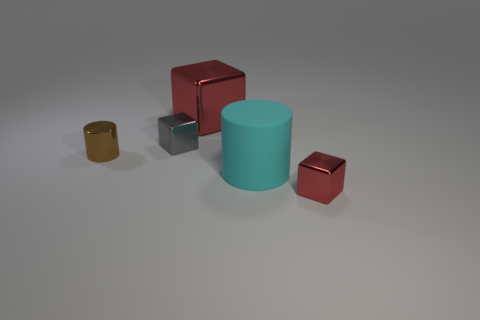Are there any other things that have the same material as the cyan cylinder?
Provide a succinct answer. No. Is there a tiny brown thing that has the same shape as the large cyan object?
Provide a succinct answer. Yes. The tiny object in front of the brown cylinder has what shape?
Keep it short and to the point. Cube. What number of big green metallic cubes are there?
Offer a terse response. 0. What color is the small cylinder that is made of the same material as the gray object?
Provide a succinct answer. Brown. What number of big objects are either purple metal cylinders or brown shiny cylinders?
Make the answer very short. 0. There is a big matte object; what number of small shiny cubes are behind it?
Make the answer very short. 1. What color is the tiny object that is the same shape as the big cyan matte thing?
Keep it short and to the point. Brown. What number of matte things are big gray cylinders or tiny objects?
Provide a succinct answer. 0. Is there a shiny object that is on the left side of the small cube behind the small block that is in front of the gray metallic block?
Your response must be concise. Yes. 